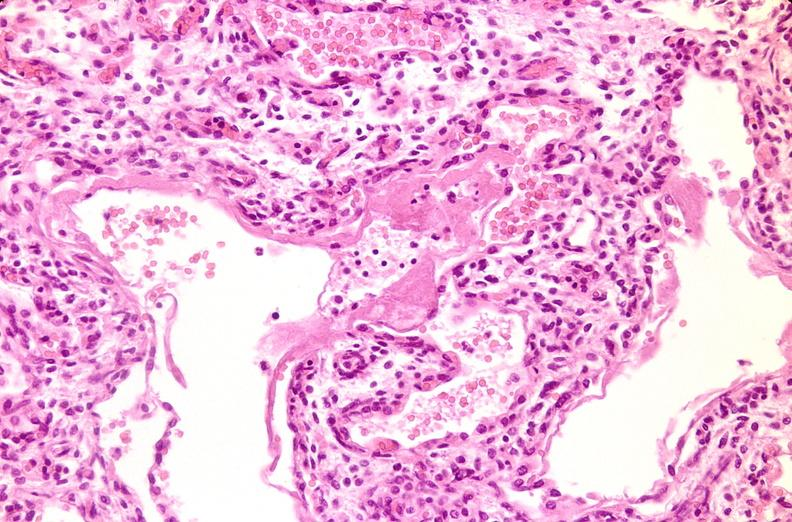does this image show lungs, hyaline membrane disease?
Answer the question using a single word or phrase. Yes 